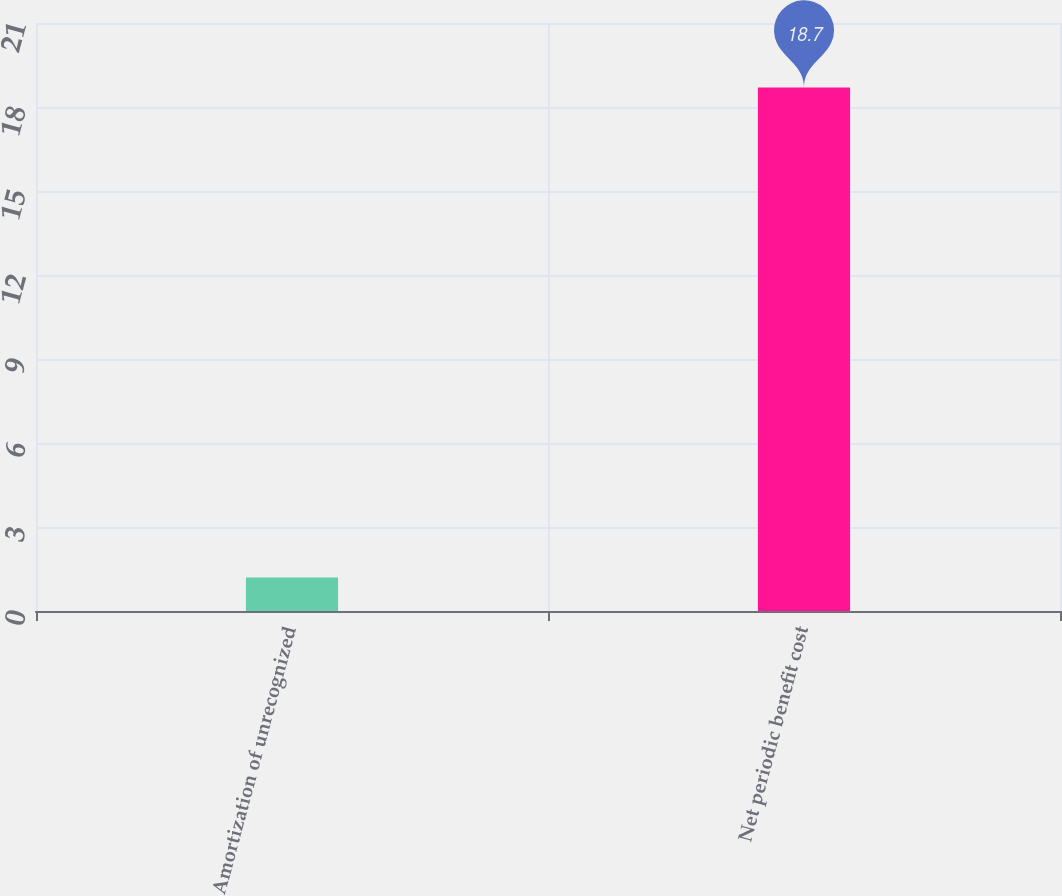<chart> <loc_0><loc_0><loc_500><loc_500><bar_chart><fcel>Amortization of unrecognized<fcel>Net periodic benefit cost<nl><fcel>1.2<fcel>18.7<nl></chart> 